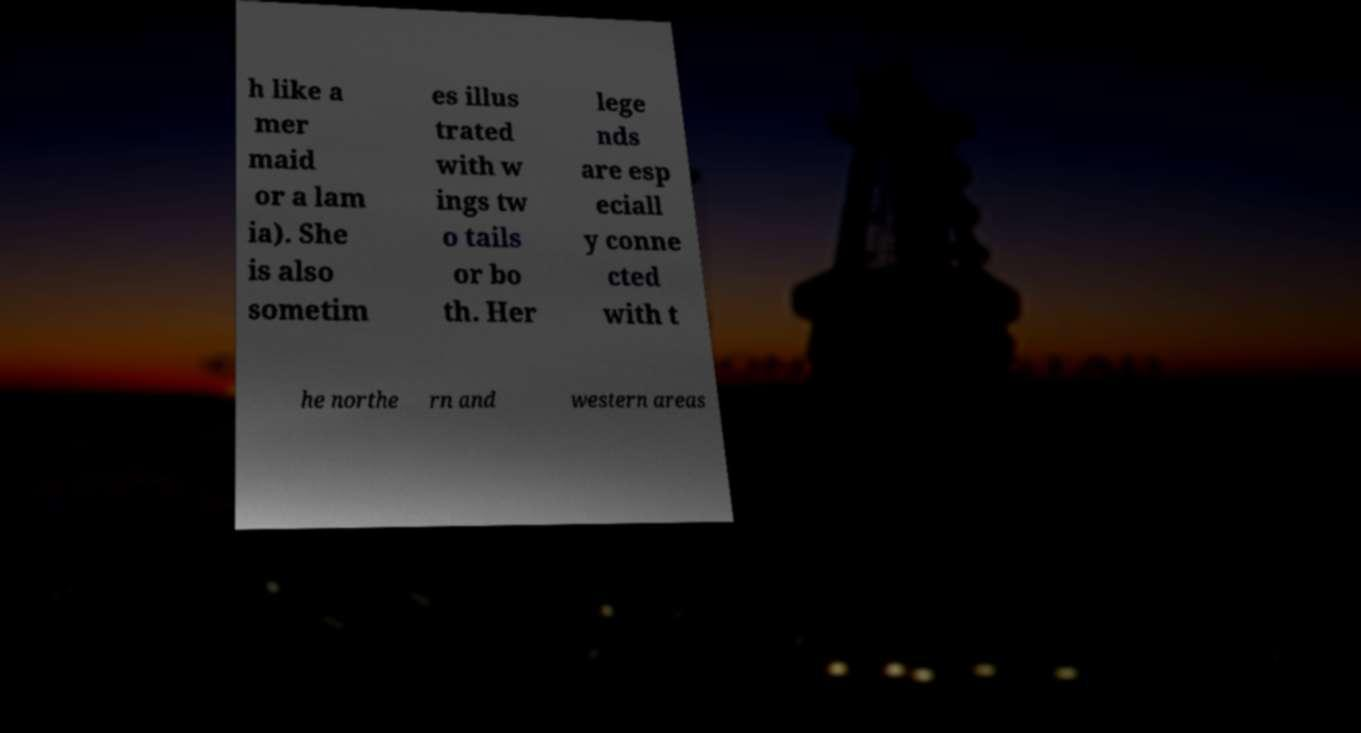Could you extract and type out the text from this image? h like a mer maid or a lam ia). She is also sometim es illus trated with w ings tw o tails or bo th. Her lege nds are esp eciall y conne cted with t he northe rn and western areas 